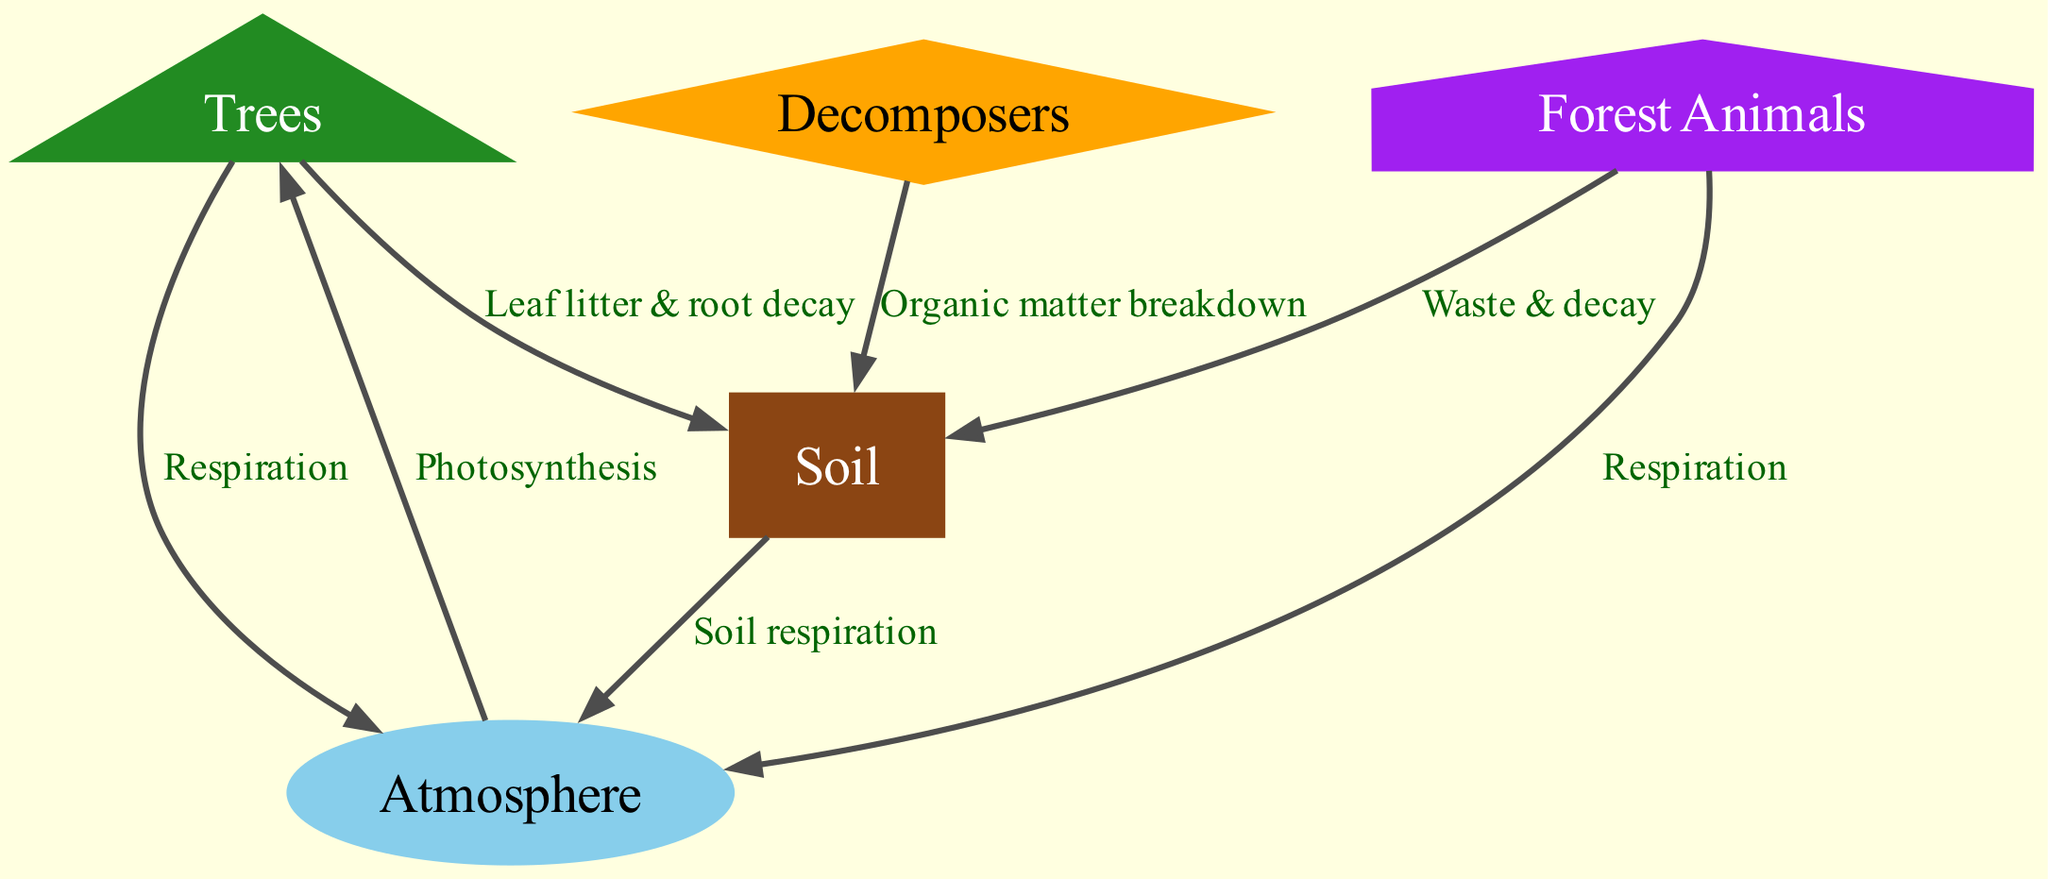What are the three main nodes in the carbon cycle? The diagram includes three main nodes: trees, soil, and atmosphere. These are key components of the carbon cycle in the forest ecosystem.
Answer: trees, soil, atmosphere What process connects the atmosphere to the trees? The connection between the atmosphere and the trees is through the process of photosynthesis, which is labeled on the directed edge going from the atmosphere to the trees.
Answer: Photosynthesis How many edges are shown in the carbon cycle diagram? Counting the connections (edges) visually represented in the diagram, there are a total of seven edges connecting the different nodes.
Answer: 7 What do forest animals contribute to the soil? Forest animals contribute waste and decay to the soil, which is illustrated as a directed edge from forest animals to soil, specifying their role in the carbon cycle.
Answer: Waste & decay Which node has a connection labeled 'Soil respiration'? The node 'soil' has a connection labeled 'Soil respiration' leading to the atmosphere, indicating the flow of carbon from soil back into the atmosphere.
Answer: soil What is the role of decomposers in the carbon cycle according to the diagram? Decomposers are shown to break down organic matter, contributing to the soil. This connection captures their essential role in returning carbon to the soil compartment of the carbon cycle.
Answer: Organic matter breakdown Which process allows trees to release carbon back into the atmosphere? The process by which trees release carbon back into the atmosphere is called respiration, which is explicitly labeled on the edge going from trees to the atmosphere.
Answer: Respiration 